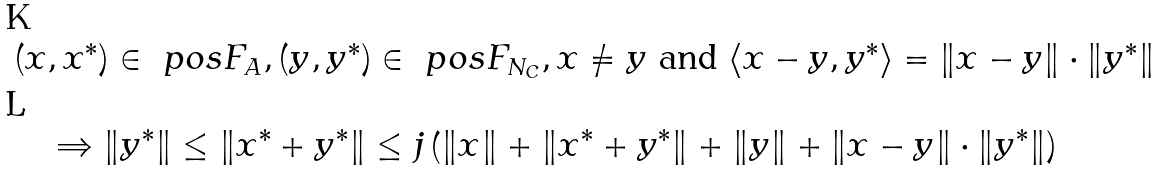<formula> <loc_0><loc_0><loc_500><loc_500>& ( x , x ^ { * } ) \in \ p o s F _ { A } , ( y , y ^ { * } ) \in \ p o s F _ { N _ { C } } , x \neq y \ \text {and} \ \langle x - y , y ^ { * } \rangle = \| x - y \| \cdot \| y ^ { * } \| \\ & \quad \Rightarrow \| y ^ { * } \| \leq \| x ^ { * } + y ^ { * } \| \leq j \left ( \| x \| + \| x ^ { * } + y ^ { * } \| + \| y \| + \| x - y \| \cdot \| y ^ { * } \| \right )</formula> 